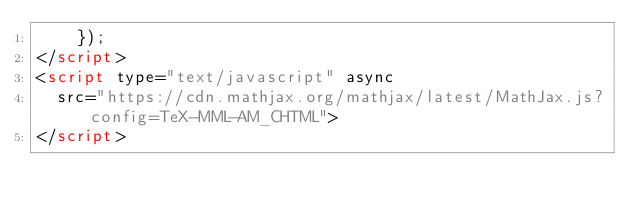Convert code to text. <code><loc_0><loc_0><loc_500><loc_500><_HTML_>	});
</script>
<script type="text/javascript" async
  src="https://cdn.mathjax.org/mathjax/latest/MathJax.js?config=TeX-MML-AM_CHTML">
</script>
</code> 